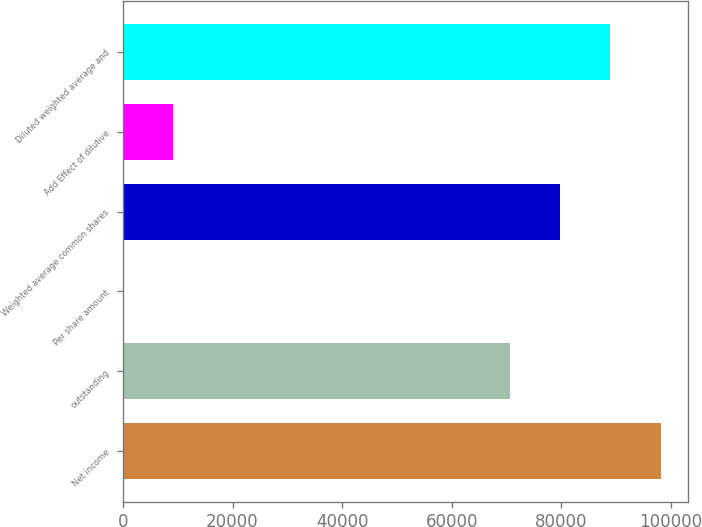Convert chart. <chart><loc_0><loc_0><loc_500><loc_500><bar_chart><fcel>Net income<fcel>outstanding<fcel>Per share amount<fcel>Weighted average common shares<fcel>Add Effect of dilutive<fcel>Diluted weighted average and<nl><fcel>98155.4<fcel>70647<fcel>1.3<fcel>79816.5<fcel>9170.77<fcel>88985.9<nl></chart> 